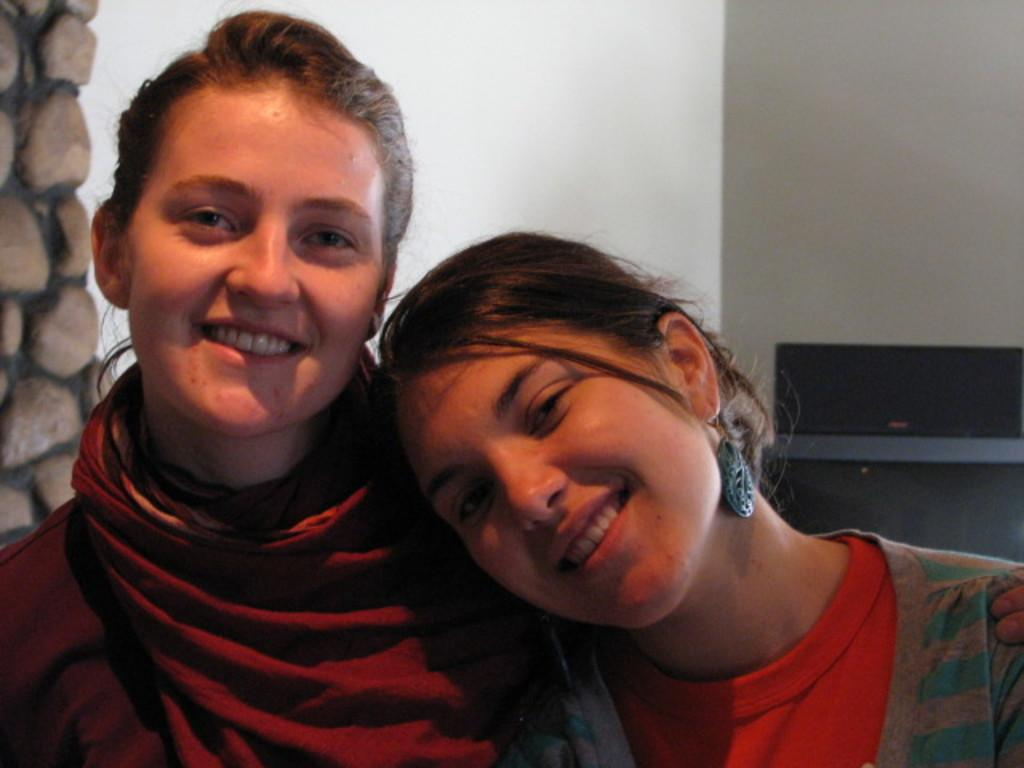How many girls are present in the image? There are two girls in the image. Where are the girls positioned in the image? The girls are sitting in the front. What is the facial expression of the girls? The girls are smiling. What are the girls doing in the image? The girls are giving a pose into the camera. What can be seen in the background of the image? There is a white wall in the background. What architectural feature is present in the left corner of the image? There is a stone pillar in the left corner of the image. What type of thread is being used by the girls in the image? There is no thread present in the image; the girls are simply posing for the camera. What is the hen's role in the image? There is no hen present in the image. 